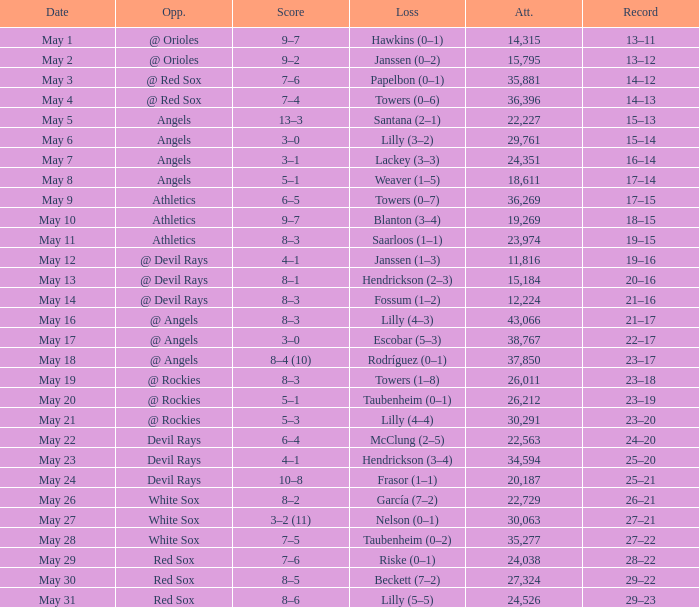What was the average attendance for games with a loss of papelbon (0–1)? 35881.0. 